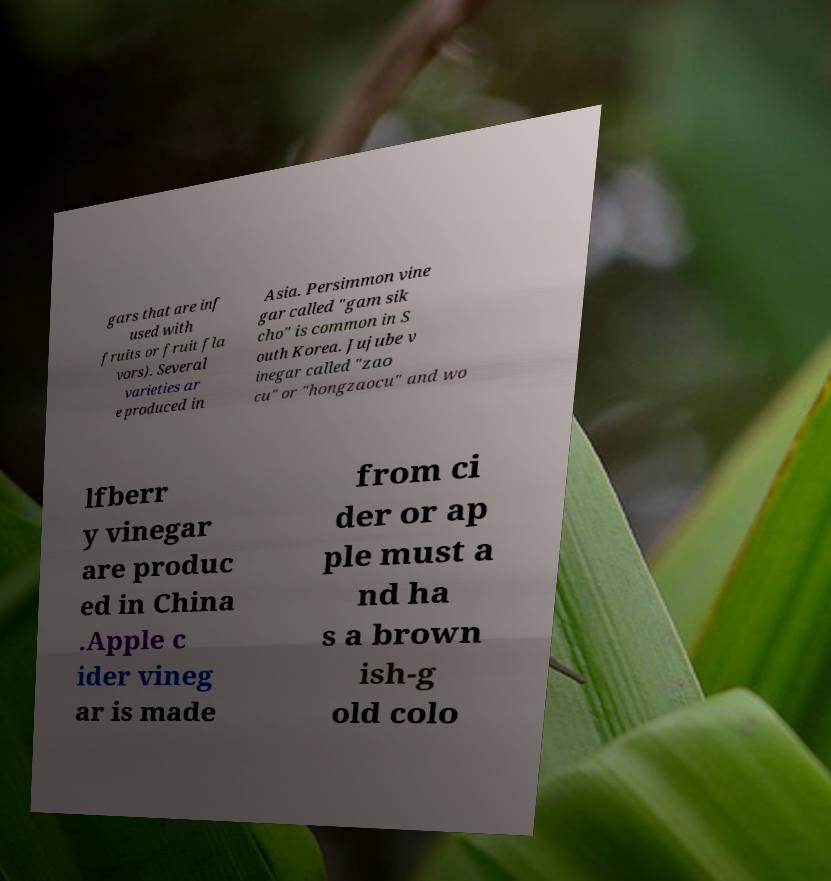For documentation purposes, I need the text within this image transcribed. Could you provide that? gars that are inf used with fruits or fruit fla vors). Several varieties ar e produced in Asia. Persimmon vine gar called "gam sik cho" is common in S outh Korea. Jujube v inegar called "zao cu" or "hongzaocu" and wo lfberr y vinegar are produc ed in China .Apple c ider vineg ar is made from ci der or ap ple must a nd ha s a brown ish-g old colo 